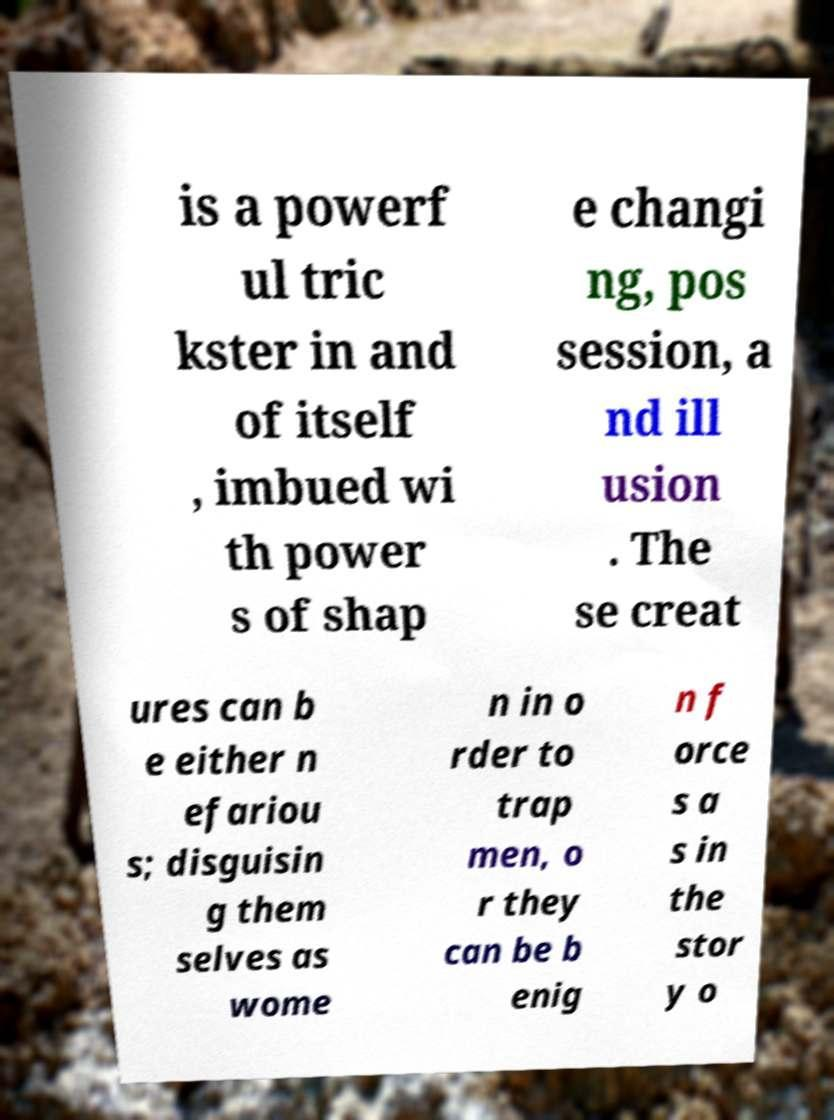For documentation purposes, I need the text within this image transcribed. Could you provide that? is a powerf ul tric kster in and of itself , imbued wi th power s of shap e changi ng, pos session, a nd ill usion . The se creat ures can b e either n efariou s; disguisin g them selves as wome n in o rder to trap men, o r they can be b enig n f orce s a s in the stor y o 